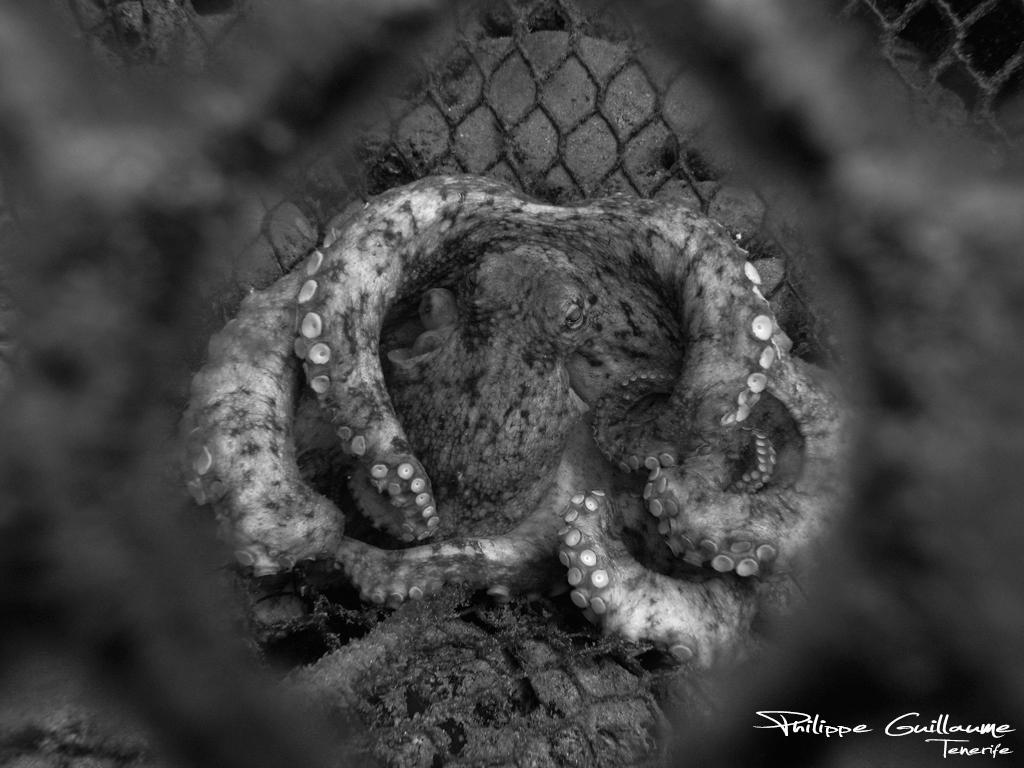What is the color scheme of the image? The image is black and white. What animal can be seen in the image? There is a snake in the image. What structure is present in the image? There is a fence in the image. Where is the text located in the image? The text is in the bottom right corner of the image. Can you hear the noise made by the sister in the image? There is no sister or noise present in the image; it only features a snake, a fence, and text. 